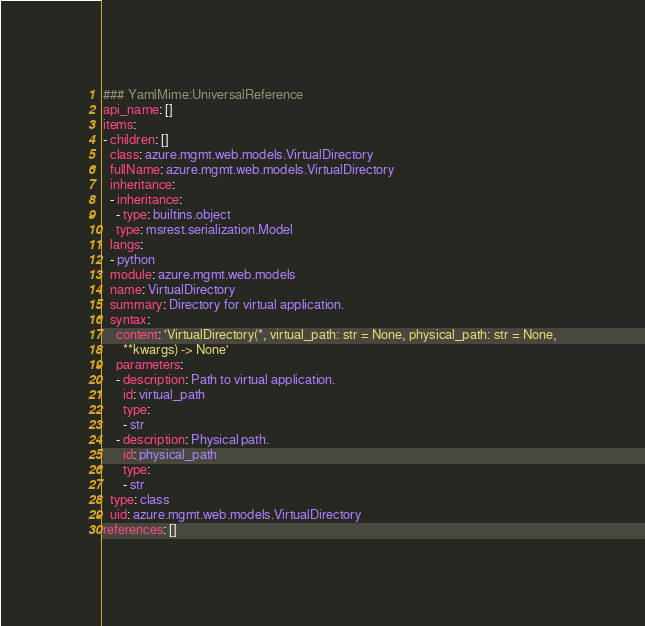Convert code to text. <code><loc_0><loc_0><loc_500><loc_500><_YAML_>### YamlMime:UniversalReference
api_name: []
items:
- children: []
  class: azure.mgmt.web.models.VirtualDirectory
  fullName: azure.mgmt.web.models.VirtualDirectory
  inheritance:
  - inheritance:
    - type: builtins.object
    type: msrest.serialization.Model
  langs:
  - python
  module: azure.mgmt.web.models
  name: VirtualDirectory
  summary: Directory for virtual application.
  syntax:
    content: 'VirtualDirectory(*, virtual_path: str = None, physical_path: str = None,
      **kwargs) -> None'
    parameters:
    - description: Path to virtual application.
      id: virtual_path
      type:
      - str
    - description: Physical path.
      id: physical_path
      type:
      - str
  type: class
  uid: azure.mgmt.web.models.VirtualDirectory
references: []
</code> 